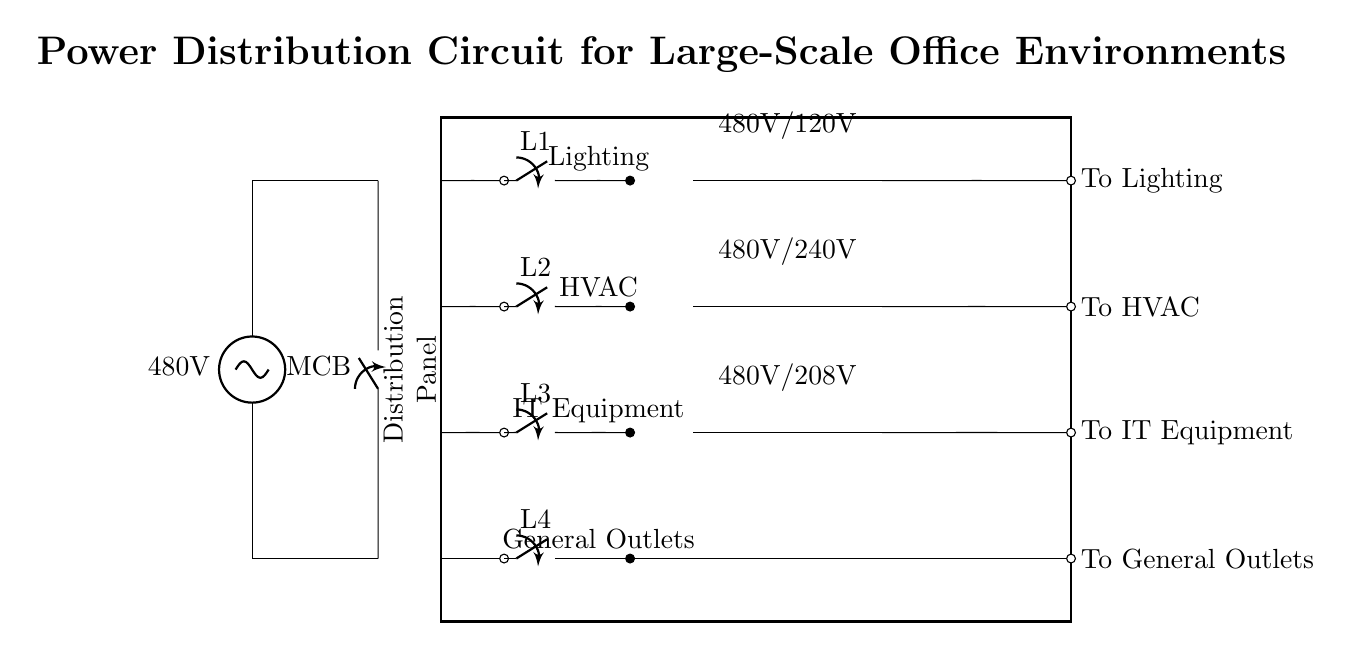What is the main voltage supplied in this circuit? The circuit is powered by a source labeled with a voltage of 480 Volts, as indicated at the top of the circuit diagram.
Answer: 480 Volts What types of transformers are used in the circuit? The circuit includes three types of transformers labeled as 480V/120V, 480V/240V, and 480V/208V, shown along the right side of the circuit diagram.
Answer: 480V/120V, 480V/240V, 480V/208V Which components are connected to the lighting circuit? The lighting circuit is connected to a switch labeled L1, which is positioned adjacent to the output labeled “To Lighting” on the right side of the diagram.
Answer: L1 What is the purpose of the main circuit breaker (MCB)? The main circuit breaker (MCB) serves as a protective device that can interrupt the flow of electricity between the power source and the distribution panel, helping to prevent overloads and short circuits.
Answer: Protective device Which component is responsible for distributing power to the HVAC circuit? The HVAC circuit is supplied power via a switch labeled L2, which connects to the distribution panel before leading to the output labeled “To HVAC”.
Answer: L2 What is the general outlet circuit labeled as in the circuit? The general outlet circuit is labeled L4, as indicated in the corresponding section that connects to the distribution panel and leads to the output labeled “To General Outlets”.
Answer: L4 How many distinct circuit branches are illustrated in the distribution panel? There are four distinct circuit branches illustrated: lighting, HVAC, IT Equipment, and General Outlets, each connected to its corresponding switch in the distribution panel.
Answer: Four 